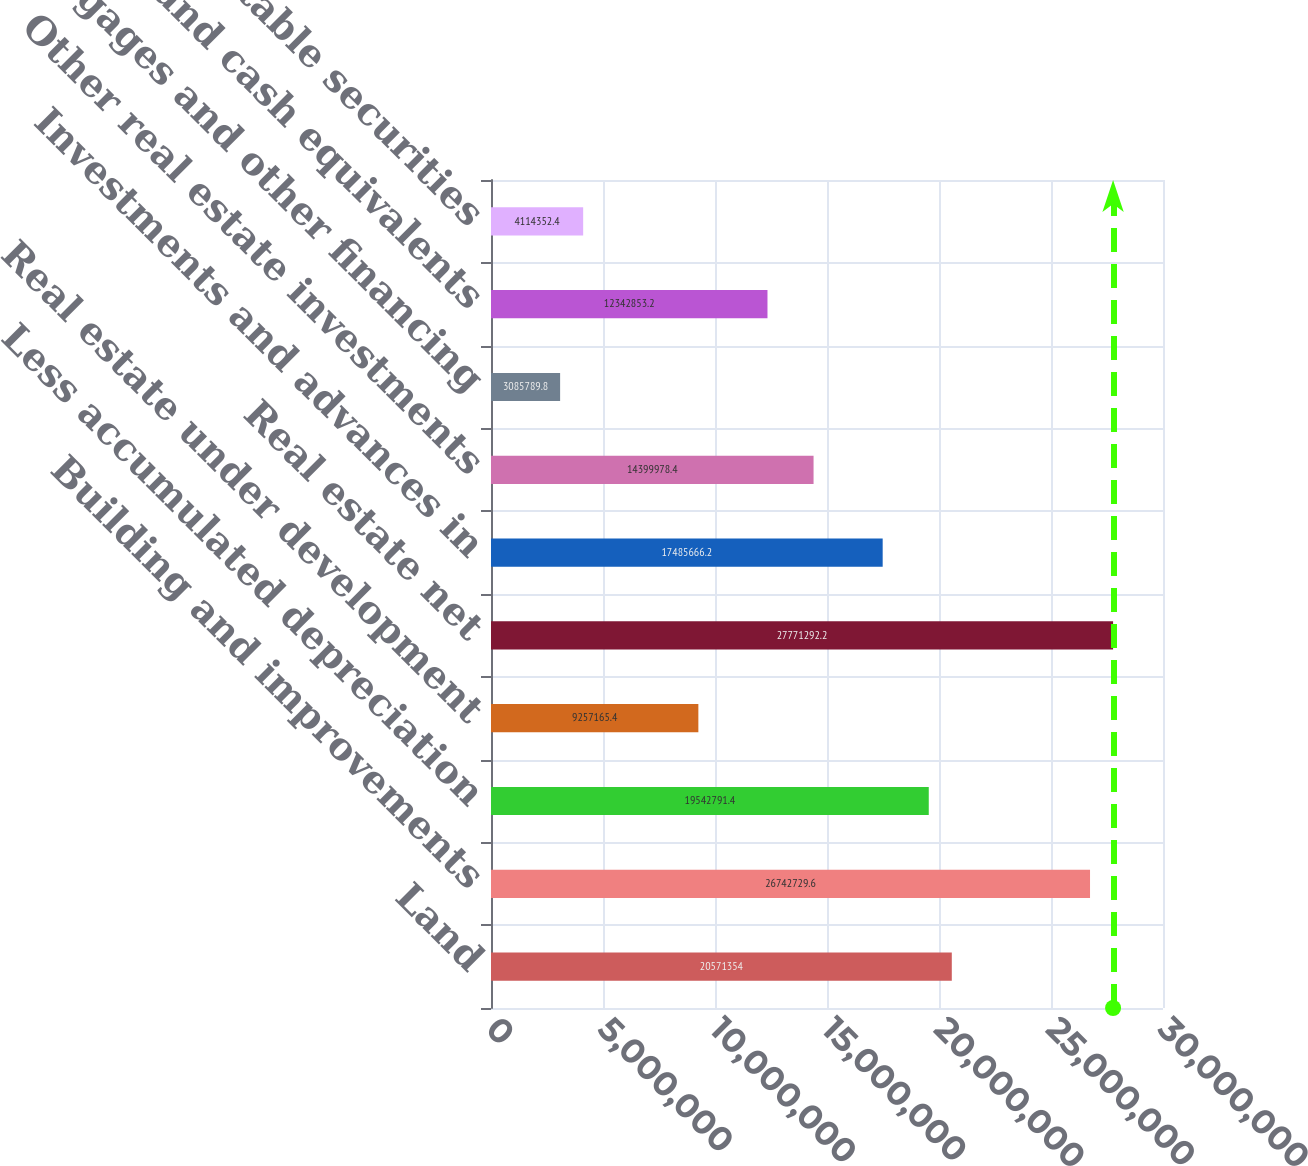Convert chart to OTSL. <chart><loc_0><loc_0><loc_500><loc_500><bar_chart><fcel>Land<fcel>Building and improvements<fcel>Less accumulated depreciation<fcel>Real estate under development<fcel>Real estate net<fcel>Investments and advances in<fcel>Other real estate investments<fcel>Mortgages and other financing<fcel>Cash and cash equivalents<fcel>Marketable securities<nl><fcel>2.05714e+07<fcel>2.67427e+07<fcel>1.95428e+07<fcel>9.25717e+06<fcel>2.77713e+07<fcel>1.74857e+07<fcel>1.44e+07<fcel>3.08579e+06<fcel>1.23429e+07<fcel>4.11435e+06<nl></chart> 